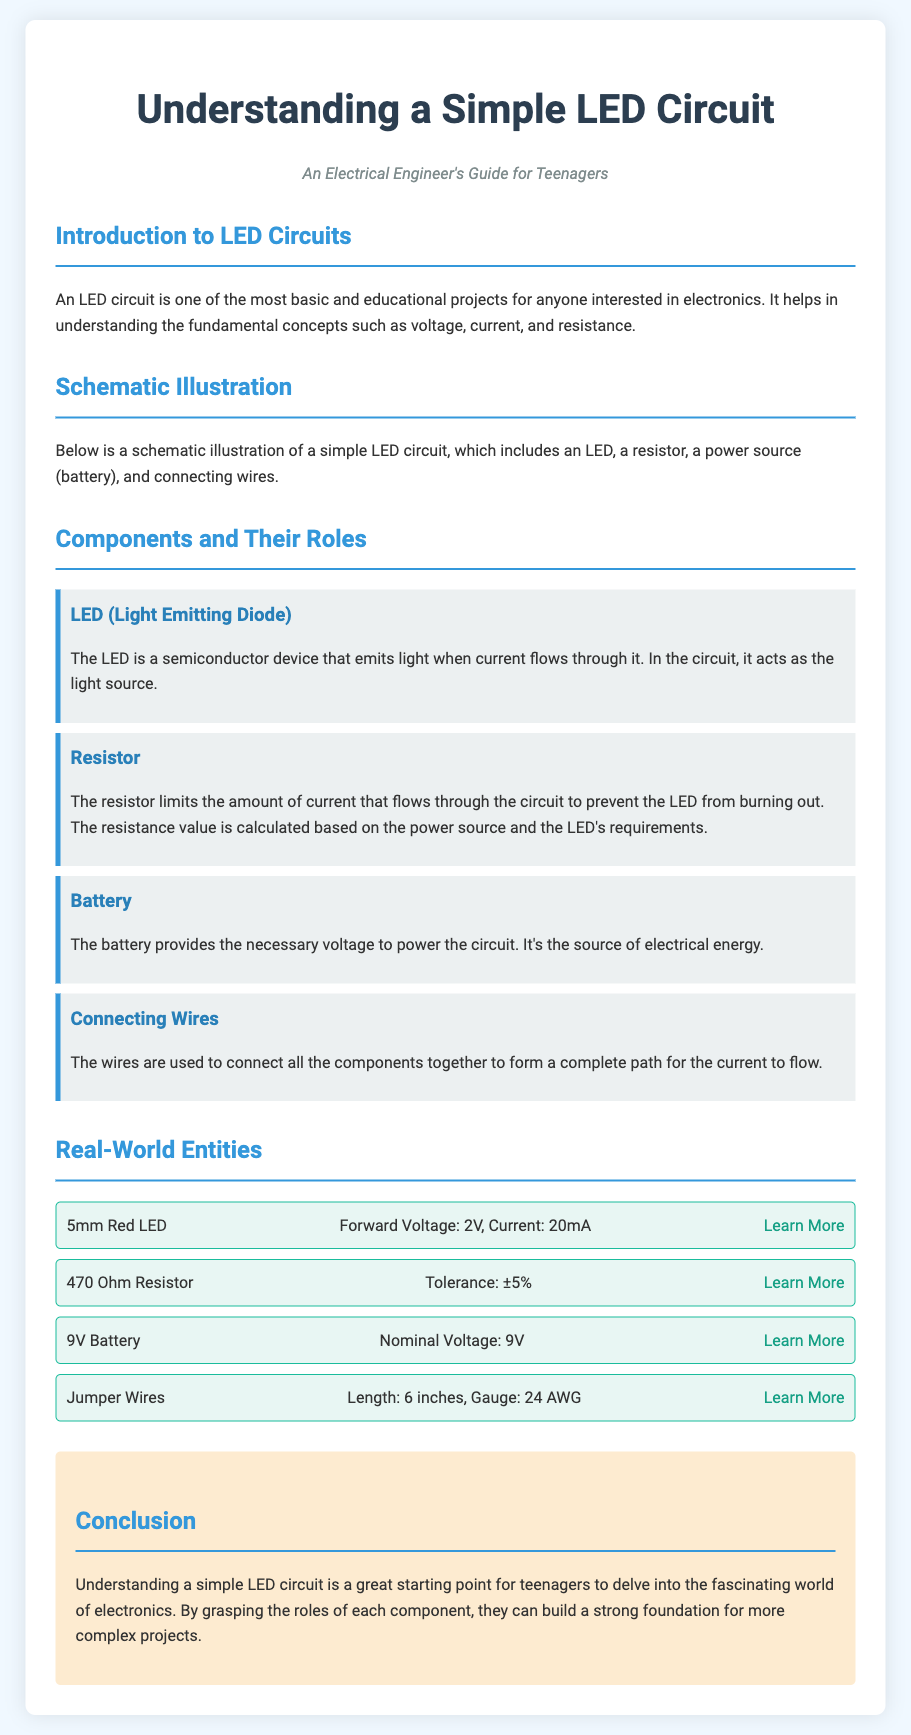What is the purpose of the LED in the circuit? The LED is a semiconductor device that emits light when current flows through it, acting as the light source.
Answer: Light source What limits the amount of current in the LED circuit? The resistor is responsible for limiting the current that flows through the circuit to prevent the LED from burning out.
Answer: Resistor What type of circuit is illustrated in the document? The document discusses a simple LED circuit that helps in understanding the fundamental concepts of electronics.
Answer: LED circuit What is the forward voltage of a 5mm Red LED? The forward voltage of the 5mm Red LED is listed as 2V in the document.
Answer: 2V How many components are mentioned in the LED circuit? The document lists four components: LED, resistor, battery, and connecting wires.
Answer: Four What is the nominal voltage of the battery used in the circuit? The nominal voltage of the battery is specified as 9V in the document.
Answer: 9V Why is understanding a simple LED circuit beneficial for teenagers? Understanding a simple LED circuit provides a strong foundation for more complex projects in electronics.
Answer: Strong foundation What is the tolerance of the 470 Ohm resistor? The tolerance of the 470 Ohm resistor is ±5%.
Answer: ±5% What does the conclusion of the document highlight? The conclusion emphasizes the importance of understanding a simple LED circuit as a starting point in electronics.
Answer: Importance of starting point 